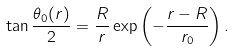Convert formula to latex. <formula><loc_0><loc_0><loc_500><loc_500>\tan \frac { \theta _ { 0 } ( r ) } { 2 } = \frac { R } { r } \exp \left ( - \frac { r - R } { r _ { 0 } } \right ) .</formula> 